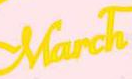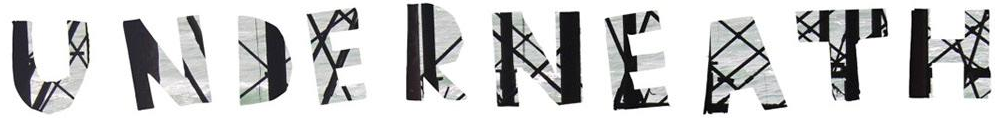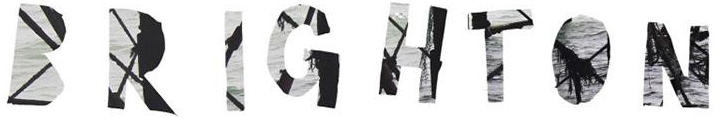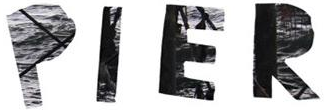Read the text content from these images in order, separated by a semicolon. March; UNDERNEATH; BRIGHTON; PIER 